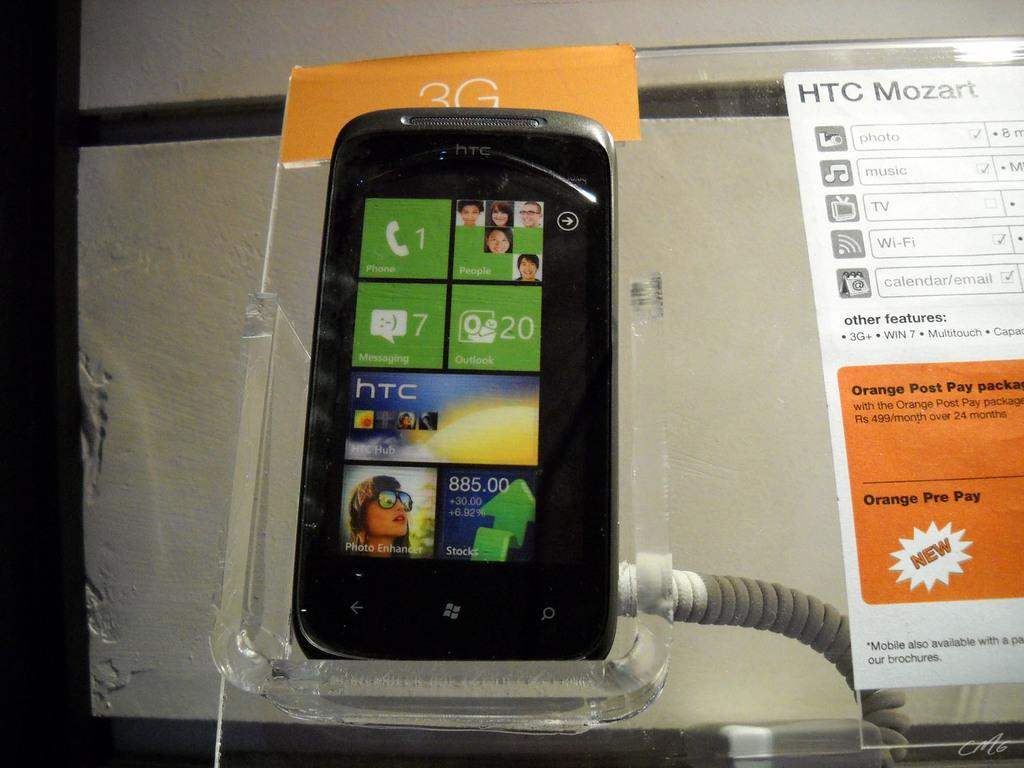<image>
Share a concise interpretation of the image provided. a phone that has the number 7 on it next to messages 